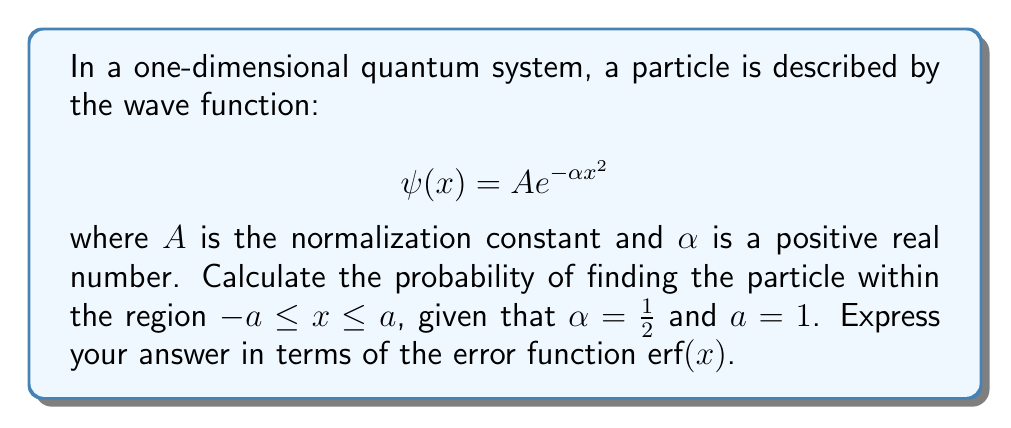Give your solution to this math problem. To solve this problem, we'll follow these steps:

1) First, we need to normalize the wave function. The normalization condition is:

   $$\int_{-\infty}^{\infty} |\psi(x)|^2 dx = 1$$

2) Substituting our wave function:

   $$\int_{-\infty}^{\infty} |Ae^{-\alpha x^2}|^2 dx = 1$$
   $$A^2\int_{-\infty}^{\infty} e^{-2\alpha x^2} dx = 1$$

3) This integral is a standard Gaussian integral. Its solution is:

   $$A^2 \sqrt{\frac{\pi}{2\alpha}} = 1$$

4) Solving for $A$:

   $$A = \left(\frac{2\alpha}{\pi}\right)^{1/4}$$

5) Now, the probability of finding the particle in the region $-a \leq x \leq a$ is given by:

   $$P(-a \leq x \leq a) = \int_{-a}^{a} |\psi(x)|^2 dx$$

6) Substituting our normalized wave function:

   $$P(-a \leq x \leq a) = \left(\frac{2\alpha}{\pi}\right)^{1/2} \int_{-a}^{a} e^{-2\alpha x^2} dx$$

7) This integral is related to the error function $\text{erf}(x)$. The relationship is:

   $$\int_{0}^{x} e^{-t^2} dt = \frac{\sqrt{\pi}}{2}\text{erf}(x)$$

8) Using this, we can rewrite our integral:

   $$P(-a \leq x \leq a) = \left(\frac{2\alpha}{\pi}\right)^{1/2} \cdot \frac{\sqrt{\pi}}{\sqrt{2\alpha}} \cdot \text{erf}(a\sqrt{2\alpha})$$

9) Simplifying:

   $$P(-a \leq x \leq a) = \text{erf}(a\sqrt{2\alpha})$$

10) Now, substituting the given values $\alpha = \frac{1}{2}$ and $a = 1$:

    $$P(-1 \leq x \leq 1) = \text{erf}(\sqrt{1}) = \text{erf}(1)$$

Thus, the probability of finding the particle within the region $-1 \leq x \leq 1$ is $\text{erf}(1)$.
Answer: $\text{erf}(1)$ (approximately 0.8427) 